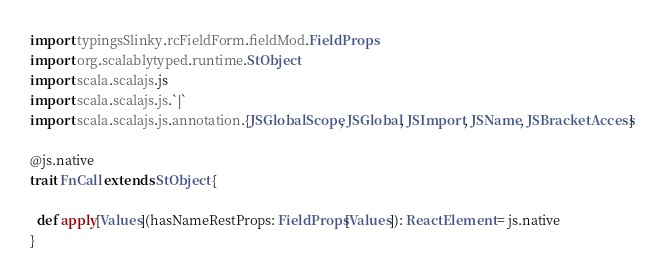<code> <loc_0><loc_0><loc_500><loc_500><_Scala_>import typingsSlinky.rcFieldForm.fieldMod.FieldProps
import org.scalablytyped.runtime.StObject
import scala.scalajs.js
import scala.scalajs.js.`|`
import scala.scalajs.js.annotation.{JSGlobalScope, JSGlobal, JSImport, JSName, JSBracketAccess}

@js.native
trait FnCall extends StObject {
  
  def apply[Values](hasNameRestProps: FieldProps[Values]): ReactElement = js.native
}
</code> 